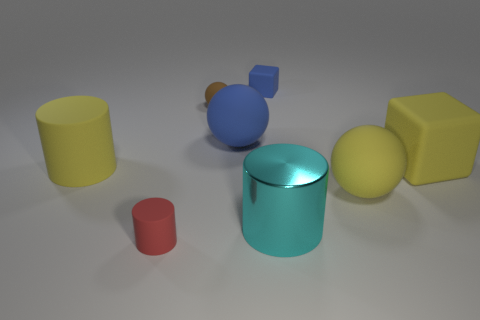The rubber object that is the same color as the tiny rubber block is what size?
Your answer should be compact. Large. The matte ball that is the same size as the blue matte cube is what color?
Provide a succinct answer. Brown. How many other objects are the same shape as the large blue rubber object?
Your answer should be compact. 2. There is a blue block; does it have the same size as the yellow rubber object that is to the left of the shiny object?
Make the answer very short. No. What number of things are either red cylinders or cyan metal objects?
Make the answer very short. 2. What number of other objects are the same size as the red cylinder?
Your answer should be compact. 2. There is a large block; does it have the same color as the sphere that is in front of the yellow cylinder?
Your answer should be compact. Yes. How many cylinders are either large cyan rubber things or cyan things?
Your answer should be very brief. 1. Is there anything else that has the same color as the small rubber cylinder?
Make the answer very short. No. What material is the cylinder to the right of the small object that is in front of the small brown rubber sphere?
Provide a short and direct response. Metal. 